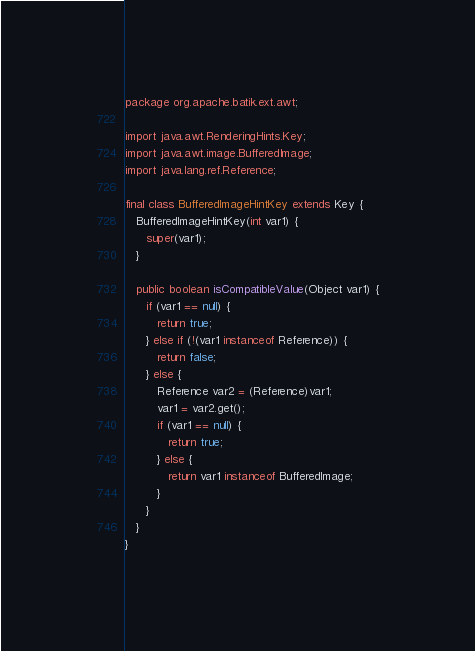Convert code to text. <code><loc_0><loc_0><loc_500><loc_500><_Java_>package org.apache.batik.ext.awt;

import java.awt.RenderingHints.Key;
import java.awt.image.BufferedImage;
import java.lang.ref.Reference;

final class BufferedImageHintKey extends Key {
   BufferedImageHintKey(int var1) {
      super(var1);
   }

   public boolean isCompatibleValue(Object var1) {
      if (var1 == null) {
         return true;
      } else if (!(var1 instanceof Reference)) {
         return false;
      } else {
         Reference var2 = (Reference)var1;
         var1 = var2.get();
         if (var1 == null) {
            return true;
         } else {
            return var1 instanceof BufferedImage;
         }
      }
   }
}
</code> 